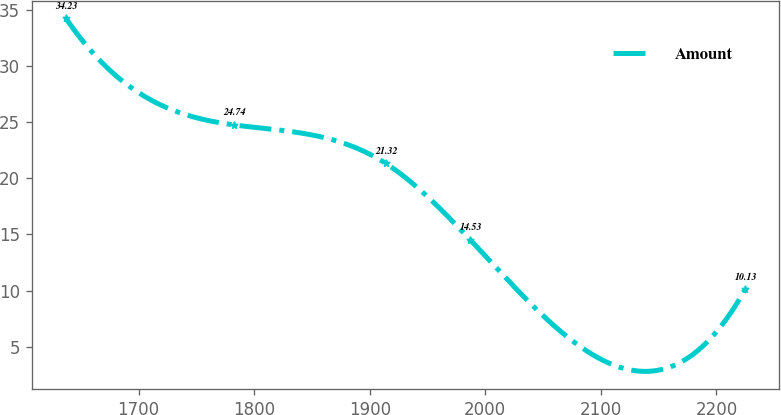<chart> <loc_0><loc_0><loc_500><loc_500><line_chart><ecel><fcel>Amount<nl><fcel>1636.98<fcel>34.23<nl><fcel>1782.6<fcel>24.74<nl><fcel>1913.79<fcel>21.32<nl><fcel>1986.87<fcel>14.53<nl><fcel>2224.99<fcel>10.13<nl></chart> 